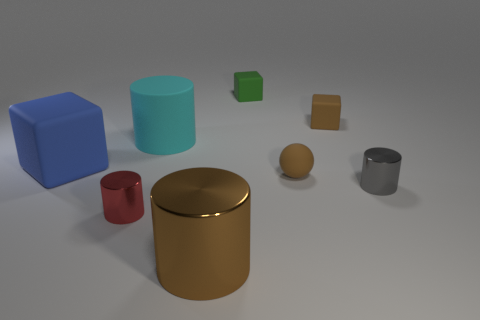How many tiny green rubber cubes are on the left side of the small brown rubber object behind the blue rubber object?
Give a very brief answer. 1. What number of other objects are the same size as the green object?
Make the answer very short. 4. There is a metallic cylinder that is the same color as the tiny sphere; what size is it?
Give a very brief answer. Large. There is a large object that is to the right of the big cyan matte cylinder; does it have the same shape as the small gray metallic thing?
Offer a terse response. Yes. What material is the tiny object that is left of the large metallic thing?
Your answer should be very brief. Metal. What shape is the shiny thing that is the same color as the small rubber sphere?
Provide a short and direct response. Cylinder. Is there a sphere made of the same material as the tiny brown block?
Ensure brevity in your answer.  Yes. How big is the cyan object?
Your answer should be compact. Large. What number of green things are big shiny things or large matte objects?
Your answer should be compact. 0. How many tiny brown metal things are the same shape as the small green rubber object?
Offer a terse response. 0. 